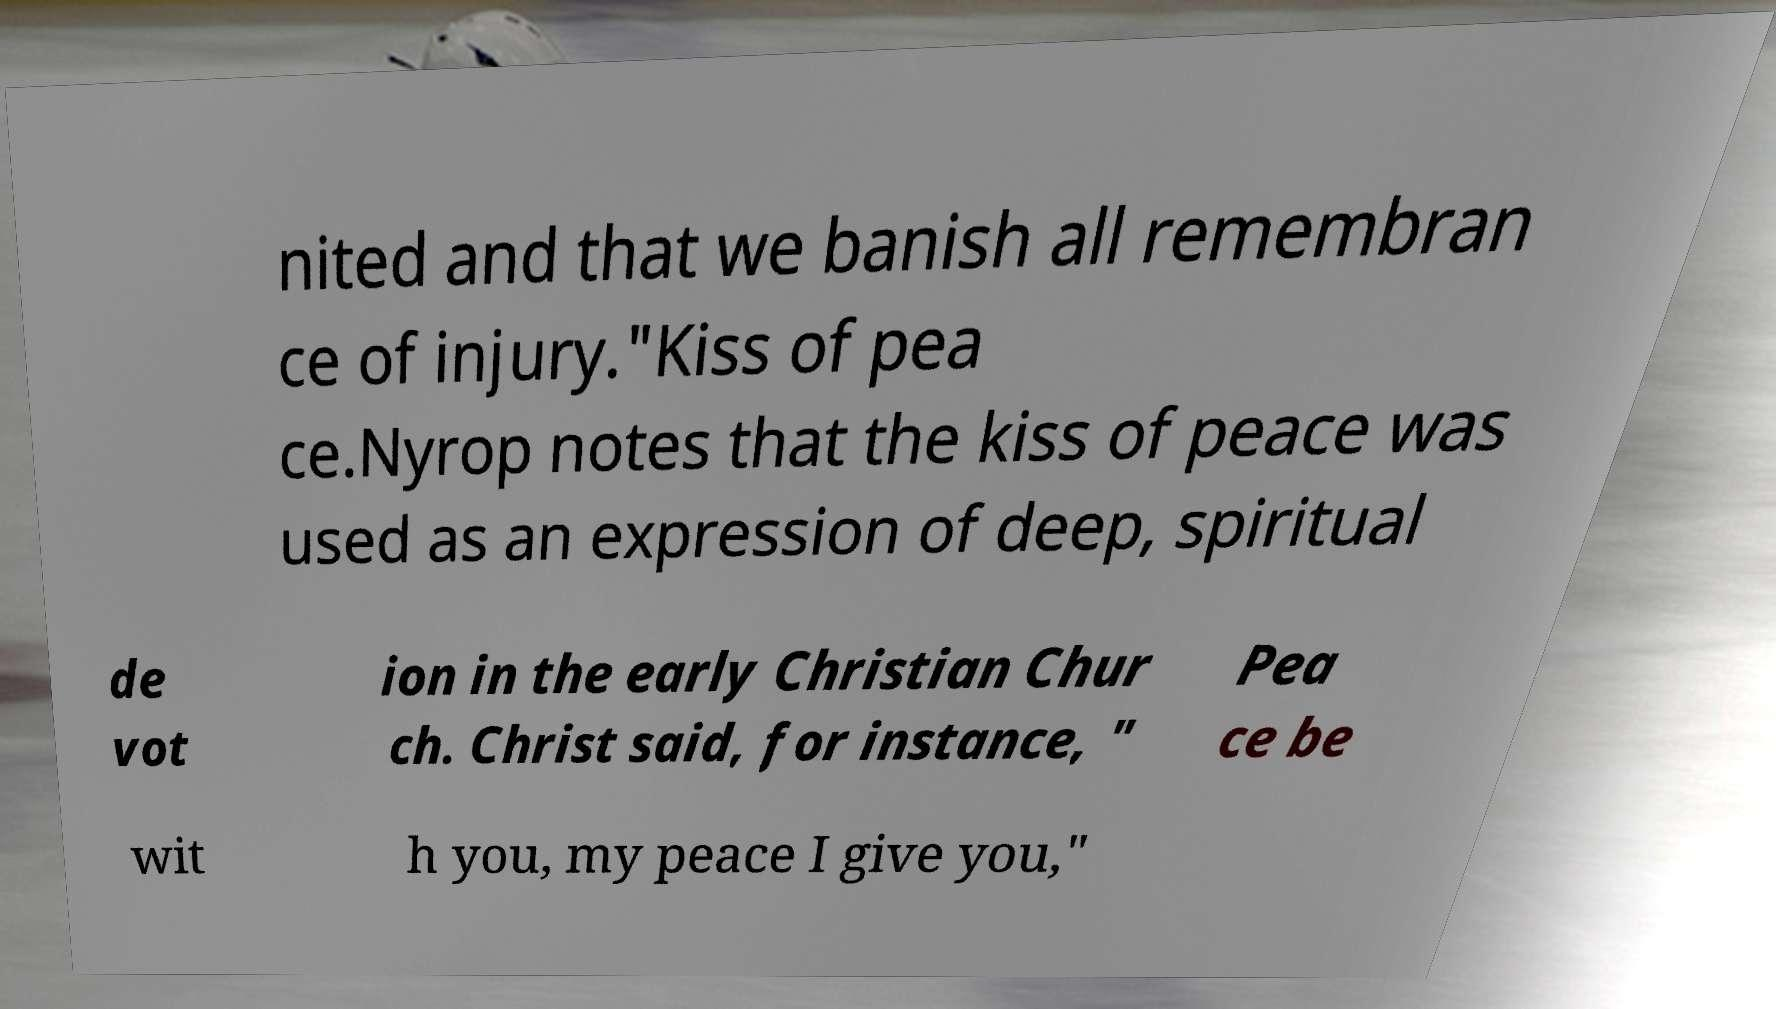Can you accurately transcribe the text from the provided image for me? nited and that we banish all remembran ce of injury."Kiss of pea ce.Nyrop notes that the kiss of peace was used as an expression of deep, spiritual de vot ion in the early Christian Chur ch. Christ said, for instance, " Pea ce be wit h you, my peace I give you," 